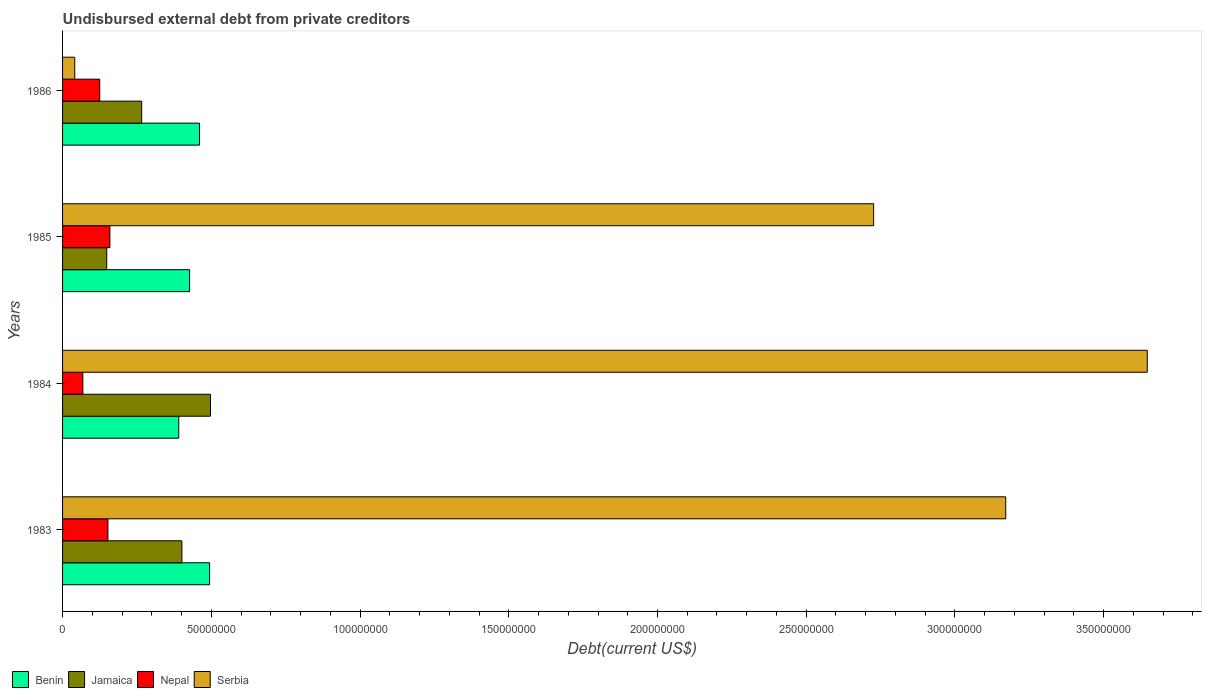How many different coloured bars are there?
Offer a terse response. 4. Are the number of bars on each tick of the Y-axis equal?
Provide a short and direct response. Yes. How many bars are there on the 4th tick from the top?
Your response must be concise. 4. In how many cases, is the number of bars for a given year not equal to the number of legend labels?
Offer a terse response. 0. What is the total debt in Jamaica in 1983?
Provide a succinct answer. 4.01e+07. Across all years, what is the maximum total debt in Nepal?
Offer a very short reply. 1.59e+07. Across all years, what is the minimum total debt in Nepal?
Keep it short and to the point. 6.82e+06. In which year was the total debt in Nepal maximum?
Provide a short and direct response. 1985. In which year was the total debt in Serbia minimum?
Keep it short and to the point. 1986. What is the total total debt in Jamaica in the graph?
Ensure brevity in your answer.  1.31e+08. What is the difference between the total debt in Benin in 1983 and that in 1984?
Offer a terse response. 1.04e+07. What is the difference between the total debt in Benin in 1985 and the total debt in Jamaica in 1986?
Offer a terse response. 1.61e+07. What is the average total debt in Nepal per year?
Ensure brevity in your answer.  1.26e+07. In the year 1986, what is the difference between the total debt in Jamaica and total debt in Benin?
Your answer should be compact. -1.94e+07. In how many years, is the total debt in Serbia greater than 210000000 US$?
Keep it short and to the point. 3. What is the ratio of the total debt in Benin in 1983 to that in 1984?
Your answer should be compact. 1.27. Is the total debt in Serbia in 1984 less than that in 1985?
Your answer should be very brief. No. What is the difference between the highest and the second highest total debt in Nepal?
Give a very brief answer. 6.63e+05. What is the difference between the highest and the lowest total debt in Benin?
Your response must be concise. 1.04e+07. In how many years, is the total debt in Nepal greater than the average total debt in Nepal taken over all years?
Provide a succinct answer. 2. Is it the case that in every year, the sum of the total debt in Serbia and total debt in Nepal is greater than the sum of total debt in Benin and total debt in Jamaica?
Provide a short and direct response. No. What does the 2nd bar from the top in 1986 represents?
Your answer should be compact. Nepal. What does the 3rd bar from the bottom in 1986 represents?
Make the answer very short. Nepal. How many bars are there?
Offer a very short reply. 16. What is the difference between two consecutive major ticks on the X-axis?
Offer a very short reply. 5.00e+07. Are the values on the major ticks of X-axis written in scientific E-notation?
Provide a succinct answer. No. Does the graph contain any zero values?
Your response must be concise. No. Does the graph contain grids?
Your answer should be compact. No. Where does the legend appear in the graph?
Provide a short and direct response. Bottom left. How are the legend labels stacked?
Keep it short and to the point. Horizontal. What is the title of the graph?
Make the answer very short. Undisbursed external debt from private creditors. What is the label or title of the X-axis?
Your answer should be very brief. Debt(current US$). What is the label or title of the Y-axis?
Provide a succinct answer. Years. What is the Debt(current US$) in Benin in 1983?
Provide a short and direct response. 4.94e+07. What is the Debt(current US$) in Jamaica in 1983?
Your response must be concise. 4.01e+07. What is the Debt(current US$) in Nepal in 1983?
Your answer should be very brief. 1.52e+07. What is the Debt(current US$) in Serbia in 1983?
Your answer should be very brief. 3.17e+08. What is the Debt(current US$) of Benin in 1984?
Offer a terse response. 3.91e+07. What is the Debt(current US$) in Jamaica in 1984?
Your answer should be very brief. 4.97e+07. What is the Debt(current US$) of Nepal in 1984?
Keep it short and to the point. 6.82e+06. What is the Debt(current US$) of Serbia in 1984?
Keep it short and to the point. 3.65e+08. What is the Debt(current US$) of Benin in 1985?
Ensure brevity in your answer.  4.27e+07. What is the Debt(current US$) of Jamaica in 1985?
Make the answer very short. 1.49e+07. What is the Debt(current US$) in Nepal in 1985?
Offer a terse response. 1.59e+07. What is the Debt(current US$) of Serbia in 1985?
Ensure brevity in your answer.  2.73e+08. What is the Debt(current US$) in Benin in 1986?
Provide a short and direct response. 4.60e+07. What is the Debt(current US$) of Jamaica in 1986?
Ensure brevity in your answer.  2.66e+07. What is the Debt(current US$) in Nepal in 1986?
Offer a very short reply. 1.25e+07. What is the Debt(current US$) in Serbia in 1986?
Your response must be concise. 4.10e+06. Across all years, what is the maximum Debt(current US$) in Benin?
Your answer should be very brief. 4.94e+07. Across all years, what is the maximum Debt(current US$) in Jamaica?
Your answer should be very brief. 4.97e+07. Across all years, what is the maximum Debt(current US$) of Nepal?
Your response must be concise. 1.59e+07. Across all years, what is the maximum Debt(current US$) of Serbia?
Give a very brief answer. 3.65e+08. Across all years, what is the minimum Debt(current US$) of Benin?
Offer a terse response. 3.91e+07. Across all years, what is the minimum Debt(current US$) of Jamaica?
Offer a very short reply. 1.49e+07. Across all years, what is the minimum Debt(current US$) in Nepal?
Provide a short and direct response. 6.82e+06. Across all years, what is the minimum Debt(current US$) in Serbia?
Your response must be concise. 4.10e+06. What is the total Debt(current US$) in Benin in the graph?
Your answer should be very brief. 1.77e+08. What is the total Debt(current US$) of Jamaica in the graph?
Offer a terse response. 1.31e+08. What is the total Debt(current US$) in Nepal in the graph?
Give a very brief answer. 5.05e+07. What is the total Debt(current US$) in Serbia in the graph?
Your response must be concise. 9.58e+08. What is the difference between the Debt(current US$) of Benin in 1983 and that in 1984?
Your answer should be compact. 1.04e+07. What is the difference between the Debt(current US$) in Jamaica in 1983 and that in 1984?
Offer a terse response. -9.62e+06. What is the difference between the Debt(current US$) in Nepal in 1983 and that in 1984?
Provide a succinct answer. 8.42e+06. What is the difference between the Debt(current US$) of Serbia in 1983 and that in 1984?
Provide a short and direct response. -4.76e+07. What is the difference between the Debt(current US$) of Benin in 1983 and that in 1985?
Your answer should be compact. 6.72e+06. What is the difference between the Debt(current US$) of Jamaica in 1983 and that in 1985?
Make the answer very short. 2.53e+07. What is the difference between the Debt(current US$) in Nepal in 1983 and that in 1985?
Make the answer very short. -6.63e+05. What is the difference between the Debt(current US$) in Serbia in 1983 and that in 1985?
Offer a very short reply. 4.44e+07. What is the difference between the Debt(current US$) in Benin in 1983 and that in 1986?
Offer a very short reply. 3.40e+06. What is the difference between the Debt(current US$) of Jamaica in 1983 and that in 1986?
Make the answer very short. 1.35e+07. What is the difference between the Debt(current US$) of Nepal in 1983 and that in 1986?
Make the answer very short. 2.74e+06. What is the difference between the Debt(current US$) of Serbia in 1983 and that in 1986?
Your answer should be compact. 3.13e+08. What is the difference between the Debt(current US$) of Benin in 1984 and that in 1985?
Your answer should be compact. -3.65e+06. What is the difference between the Debt(current US$) of Jamaica in 1984 and that in 1985?
Give a very brief answer. 3.49e+07. What is the difference between the Debt(current US$) in Nepal in 1984 and that in 1985?
Your answer should be very brief. -9.08e+06. What is the difference between the Debt(current US$) of Serbia in 1984 and that in 1985?
Provide a succinct answer. 9.20e+07. What is the difference between the Debt(current US$) in Benin in 1984 and that in 1986?
Provide a succinct answer. -6.97e+06. What is the difference between the Debt(current US$) in Jamaica in 1984 and that in 1986?
Your answer should be very brief. 2.31e+07. What is the difference between the Debt(current US$) in Nepal in 1984 and that in 1986?
Ensure brevity in your answer.  -5.68e+06. What is the difference between the Debt(current US$) in Serbia in 1984 and that in 1986?
Provide a succinct answer. 3.61e+08. What is the difference between the Debt(current US$) in Benin in 1985 and that in 1986?
Make the answer very short. -3.32e+06. What is the difference between the Debt(current US$) of Jamaica in 1985 and that in 1986?
Your response must be concise. -1.17e+07. What is the difference between the Debt(current US$) of Nepal in 1985 and that in 1986?
Offer a terse response. 3.41e+06. What is the difference between the Debt(current US$) of Serbia in 1985 and that in 1986?
Keep it short and to the point. 2.69e+08. What is the difference between the Debt(current US$) of Benin in 1983 and the Debt(current US$) of Jamaica in 1984?
Your answer should be very brief. -3.07e+05. What is the difference between the Debt(current US$) of Benin in 1983 and the Debt(current US$) of Nepal in 1984?
Your answer should be very brief. 4.26e+07. What is the difference between the Debt(current US$) of Benin in 1983 and the Debt(current US$) of Serbia in 1984?
Your answer should be very brief. -3.15e+08. What is the difference between the Debt(current US$) in Jamaica in 1983 and the Debt(current US$) in Nepal in 1984?
Keep it short and to the point. 3.33e+07. What is the difference between the Debt(current US$) in Jamaica in 1983 and the Debt(current US$) in Serbia in 1984?
Your response must be concise. -3.25e+08. What is the difference between the Debt(current US$) of Nepal in 1983 and the Debt(current US$) of Serbia in 1984?
Provide a succinct answer. -3.49e+08. What is the difference between the Debt(current US$) in Benin in 1983 and the Debt(current US$) in Jamaica in 1985?
Keep it short and to the point. 3.46e+07. What is the difference between the Debt(current US$) in Benin in 1983 and the Debt(current US$) in Nepal in 1985?
Your answer should be very brief. 3.35e+07. What is the difference between the Debt(current US$) in Benin in 1983 and the Debt(current US$) in Serbia in 1985?
Make the answer very short. -2.23e+08. What is the difference between the Debt(current US$) in Jamaica in 1983 and the Debt(current US$) in Nepal in 1985?
Provide a short and direct response. 2.42e+07. What is the difference between the Debt(current US$) in Jamaica in 1983 and the Debt(current US$) in Serbia in 1985?
Your answer should be very brief. -2.33e+08. What is the difference between the Debt(current US$) of Nepal in 1983 and the Debt(current US$) of Serbia in 1985?
Make the answer very short. -2.57e+08. What is the difference between the Debt(current US$) in Benin in 1983 and the Debt(current US$) in Jamaica in 1986?
Your answer should be very brief. 2.28e+07. What is the difference between the Debt(current US$) in Benin in 1983 and the Debt(current US$) in Nepal in 1986?
Provide a short and direct response. 3.69e+07. What is the difference between the Debt(current US$) of Benin in 1983 and the Debt(current US$) of Serbia in 1986?
Your answer should be compact. 4.53e+07. What is the difference between the Debt(current US$) in Jamaica in 1983 and the Debt(current US$) in Nepal in 1986?
Provide a short and direct response. 2.76e+07. What is the difference between the Debt(current US$) of Jamaica in 1983 and the Debt(current US$) of Serbia in 1986?
Your answer should be very brief. 3.60e+07. What is the difference between the Debt(current US$) in Nepal in 1983 and the Debt(current US$) in Serbia in 1986?
Make the answer very short. 1.11e+07. What is the difference between the Debt(current US$) of Benin in 1984 and the Debt(current US$) of Jamaica in 1985?
Offer a very short reply. 2.42e+07. What is the difference between the Debt(current US$) of Benin in 1984 and the Debt(current US$) of Nepal in 1985?
Ensure brevity in your answer.  2.31e+07. What is the difference between the Debt(current US$) of Benin in 1984 and the Debt(current US$) of Serbia in 1985?
Your answer should be compact. -2.34e+08. What is the difference between the Debt(current US$) in Jamaica in 1984 and the Debt(current US$) in Nepal in 1985?
Your answer should be compact. 3.38e+07. What is the difference between the Debt(current US$) of Jamaica in 1984 and the Debt(current US$) of Serbia in 1985?
Your answer should be compact. -2.23e+08. What is the difference between the Debt(current US$) of Nepal in 1984 and the Debt(current US$) of Serbia in 1985?
Give a very brief answer. -2.66e+08. What is the difference between the Debt(current US$) in Benin in 1984 and the Debt(current US$) in Jamaica in 1986?
Your response must be concise. 1.25e+07. What is the difference between the Debt(current US$) of Benin in 1984 and the Debt(current US$) of Nepal in 1986?
Ensure brevity in your answer.  2.66e+07. What is the difference between the Debt(current US$) of Benin in 1984 and the Debt(current US$) of Serbia in 1986?
Offer a terse response. 3.50e+07. What is the difference between the Debt(current US$) of Jamaica in 1984 and the Debt(current US$) of Nepal in 1986?
Your answer should be compact. 3.72e+07. What is the difference between the Debt(current US$) in Jamaica in 1984 and the Debt(current US$) in Serbia in 1986?
Your answer should be very brief. 4.56e+07. What is the difference between the Debt(current US$) of Nepal in 1984 and the Debt(current US$) of Serbia in 1986?
Make the answer very short. 2.72e+06. What is the difference between the Debt(current US$) in Benin in 1985 and the Debt(current US$) in Jamaica in 1986?
Your answer should be compact. 1.61e+07. What is the difference between the Debt(current US$) in Benin in 1985 and the Debt(current US$) in Nepal in 1986?
Your answer should be very brief. 3.02e+07. What is the difference between the Debt(current US$) in Benin in 1985 and the Debt(current US$) in Serbia in 1986?
Offer a very short reply. 3.86e+07. What is the difference between the Debt(current US$) in Jamaica in 1985 and the Debt(current US$) in Nepal in 1986?
Give a very brief answer. 2.35e+06. What is the difference between the Debt(current US$) of Jamaica in 1985 and the Debt(current US$) of Serbia in 1986?
Offer a terse response. 1.08e+07. What is the difference between the Debt(current US$) in Nepal in 1985 and the Debt(current US$) in Serbia in 1986?
Offer a very short reply. 1.18e+07. What is the average Debt(current US$) of Benin per year?
Ensure brevity in your answer.  4.43e+07. What is the average Debt(current US$) of Jamaica per year?
Your answer should be very brief. 3.28e+07. What is the average Debt(current US$) of Nepal per year?
Your response must be concise. 1.26e+07. What is the average Debt(current US$) in Serbia per year?
Offer a terse response. 2.40e+08. In the year 1983, what is the difference between the Debt(current US$) of Benin and Debt(current US$) of Jamaica?
Offer a terse response. 9.31e+06. In the year 1983, what is the difference between the Debt(current US$) in Benin and Debt(current US$) in Nepal?
Your answer should be very brief. 3.42e+07. In the year 1983, what is the difference between the Debt(current US$) in Benin and Debt(current US$) in Serbia?
Provide a short and direct response. -2.68e+08. In the year 1983, what is the difference between the Debt(current US$) in Jamaica and Debt(current US$) in Nepal?
Ensure brevity in your answer.  2.49e+07. In the year 1983, what is the difference between the Debt(current US$) of Jamaica and Debt(current US$) of Serbia?
Ensure brevity in your answer.  -2.77e+08. In the year 1983, what is the difference between the Debt(current US$) in Nepal and Debt(current US$) in Serbia?
Keep it short and to the point. -3.02e+08. In the year 1984, what is the difference between the Debt(current US$) of Benin and Debt(current US$) of Jamaica?
Provide a succinct answer. -1.07e+07. In the year 1984, what is the difference between the Debt(current US$) in Benin and Debt(current US$) in Nepal?
Provide a short and direct response. 3.22e+07. In the year 1984, what is the difference between the Debt(current US$) of Benin and Debt(current US$) of Serbia?
Ensure brevity in your answer.  -3.26e+08. In the year 1984, what is the difference between the Debt(current US$) in Jamaica and Debt(current US$) in Nepal?
Give a very brief answer. 4.29e+07. In the year 1984, what is the difference between the Debt(current US$) of Jamaica and Debt(current US$) of Serbia?
Your answer should be very brief. -3.15e+08. In the year 1984, what is the difference between the Debt(current US$) of Nepal and Debt(current US$) of Serbia?
Your answer should be compact. -3.58e+08. In the year 1985, what is the difference between the Debt(current US$) of Benin and Debt(current US$) of Jamaica?
Keep it short and to the point. 2.79e+07. In the year 1985, what is the difference between the Debt(current US$) in Benin and Debt(current US$) in Nepal?
Your answer should be compact. 2.68e+07. In the year 1985, what is the difference between the Debt(current US$) of Benin and Debt(current US$) of Serbia?
Provide a succinct answer. -2.30e+08. In the year 1985, what is the difference between the Debt(current US$) of Jamaica and Debt(current US$) of Nepal?
Your response must be concise. -1.06e+06. In the year 1985, what is the difference between the Debt(current US$) of Jamaica and Debt(current US$) of Serbia?
Your response must be concise. -2.58e+08. In the year 1985, what is the difference between the Debt(current US$) in Nepal and Debt(current US$) in Serbia?
Provide a short and direct response. -2.57e+08. In the year 1986, what is the difference between the Debt(current US$) in Benin and Debt(current US$) in Jamaica?
Ensure brevity in your answer.  1.94e+07. In the year 1986, what is the difference between the Debt(current US$) in Benin and Debt(current US$) in Nepal?
Ensure brevity in your answer.  3.35e+07. In the year 1986, what is the difference between the Debt(current US$) of Benin and Debt(current US$) of Serbia?
Your answer should be compact. 4.19e+07. In the year 1986, what is the difference between the Debt(current US$) in Jamaica and Debt(current US$) in Nepal?
Your response must be concise. 1.41e+07. In the year 1986, what is the difference between the Debt(current US$) in Jamaica and Debt(current US$) in Serbia?
Your answer should be compact. 2.25e+07. In the year 1986, what is the difference between the Debt(current US$) of Nepal and Debt(current US$) of Serbia?
Your answer should be very brief. 8.40e+06. What is the ratio of the Debt(current US$) of Benin in 1983 to that in 1984?
Your answer should be very brief. 1.27. What is the ratio of the Debt(current US$) in Jamaica in 1983 to that in 1984?
Give a very brief answer. 0.81. What is the ratio of the Debt(current US$) in Nepal in 1983 to that in 1984?
Give a very brief answer. 2.23. What is the ratio of the Debt(current US$) in Serbia in 1983 to that in 1984?
Make the answer very short. 0.87. What is the ratio of the Debt(current US$) in Benin in 1983 to that in 1985?
Your response must be concise. 1.16. What is the ratio of the Debt(current US$) of Jamaica in 1983 to that in 1985?
Provide a short and direct response. 2.7. What is the ratio of the Debt(current US$) in Serbia in 1983 to that in 1985?
Keep it short and to the point. 1.16. What is the ratio of the Debt(current US$) in Benin in 1983 to that in 1986?
Keep it short and to the point. 1.07. What is the ratio of the Debt(current US$) of Jamaica in 1983 to that in 1986?
Make the answer very short. 1.51. What is the ratio of the Debt(current US$) of Nepal in 1983 to that in 1986?
Make the answer very short. 1.22. What is the ratio of the Debt(current US$) of Serbia in 1983 to that in 1986?
Your answer should be compact. 77.32. What is the ratio of the Debt(current US$) in Benin in 1984 to that in 1985?
Offer a terse response. 0.91. What is the ratio of the Debt(current US$) in Jamaica in 1984 to that in 1985?
Provide a succinct answer. 3.35. What is the ratio of the Debt(current US$) of Nepal in 1984 to that in 1985?
Make the answer very short. 0.43. What is the ratio of the Debt(current US$) of Serbia in 1984 to that in 1985?
Your answer should be very brief. 1.34. What is the ratio of the Debt(current US$) in Benin in 1984 to that in 1986?
Ensure brevity in your answer.  0.85. What is the ratio of the Debt(current US$) in Jamaica in 1984 to that in 1986?
Your answer should be very brief. 1.87. What is the ratio of the Debt(current US$) in Nepal in 1984 to that in 1986?
Make the answer very short. 0.55. What is the ratio of the Debt(current US$) of Serbia in 1984 to that in 1986?
Keep it short and to the point. 88.92. What is the ratio of the Debt(current US$) in Benin in 1985 to that in 1986?
Make the answer very short. 0.93. What is the ratio of the Debt(current US$) in Jamaica in 1985 to that in 1986?
Your answer should be very brief. 0.56. What is the ratio of the Debt(current US$) in Nepal in 1985 to that in 1986?
Ensure brevity in your answer.  1.27. What is the ratio of the Debt(current US$) of Serbia in 1985 to that in 1986?
Make the answer very short. 66.49. What is the difference between the highest and the second highest Debt(current US$) in Benin?
Ensure brevity in your answer.  3.40e+06. What is the difference between the highest and the second highest Debt(current US$) of Jamaica?
Your response must be concise. 9.62e+06. What is the difference between the highest and the second highest Debt(current US$) of Nepal?
Give a very brief answer. 6.63e+05. What is the difference between the highest and the second highest Debt(current US$) of Serbia?
Offer a terse response. 4.76e+07. What is the difference between the highest and the lowest Debt(current US$) of Benin?
Keep it short and to the point. 1.04e+07. What is the difference between the highest and the lowest Debt(current US$) of Jamaica?
Your answer should be compact. 3.49e+07. What is the difference between the highest and the lowest Debt(current US$) of Nepal?
Ensure brevity in your answer.  9.08e+06. What is the difference between the highest and the lowest Debt(current US$) of Serbia?
Provide a succinct answer. 3.61e+08. 